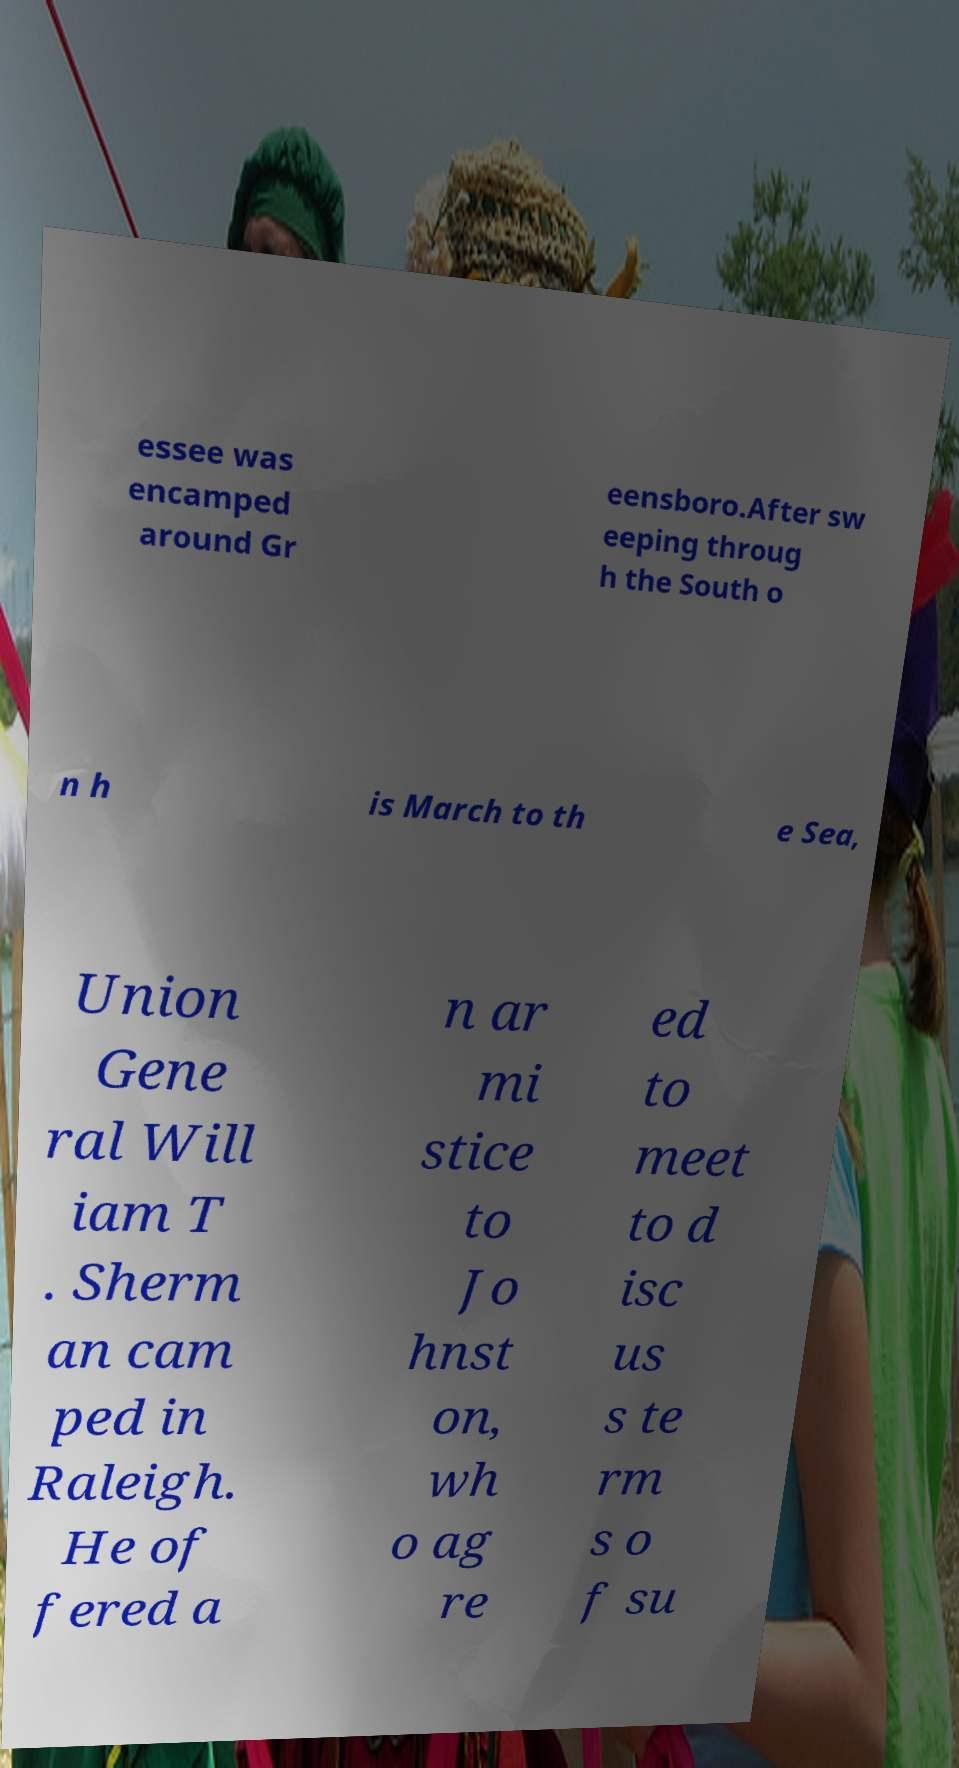Can you accurately transcribe the text from the provided image for me? essee was encamped around Gr eensboro.After sw eeping throug h the South o n h is March to th e Sea, Union Gene ral Will iam T . Sherm an cam ped in Raleigh. He of fered a n ar mi stice to Jo hnst on, wh o ag re ed to meet to d isc us s te rm s o f su 